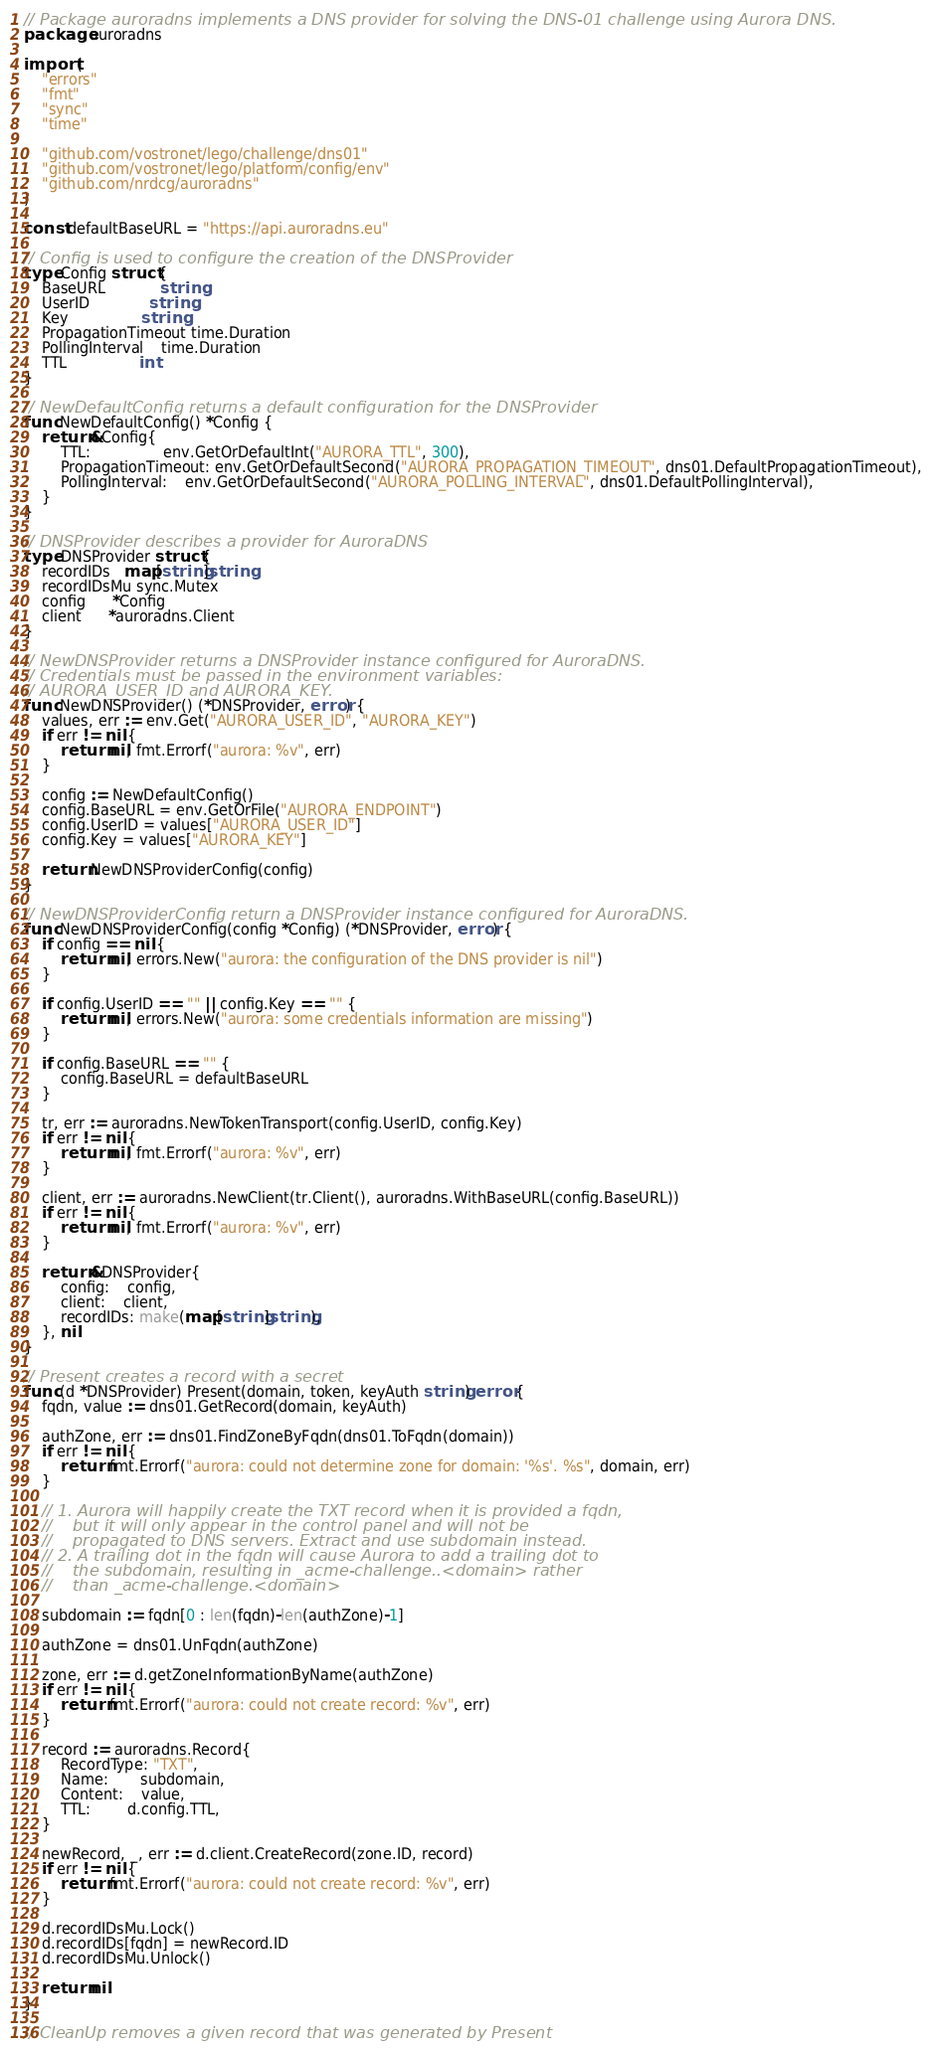<code> <loc_0><loc_0><loc_500><loc_500><_Go_>// Package auroradns implements a DNS provider for solving the DNS-01 challenge using Aurora DNS.
package auroradns

import (
	"errors"
	"fmt"
	"sync"
	"time"

	"github.com/vostronet/lego/challenge/dns01"
	"github.com/vostronet/lego/platform/config/env"
	"github.com/nrdcg/auroradns"
)

const defaultBaseURL = "https://api.auroradns.eu"

// Config is used to configure the creation of the DNSProvider
type Config struct {
	BaseURL            string
	UserID             string
	Key                string
	PropagationTimeout time.Duration
	PollingInterval    time.Duration
	TTL                int
}

// NewDefaultConfig returns a default configuration for the DNSProvider
func NewDefaultConfig() *Config {
	return &Config{
		TTL:                env.GetOrDefaultInt("AURORA_TTL", 300),
		PropagationTimeout: env.GetOrDefaultSecond("AURORA_PROPAGATION_TIMEOUT", dns01.DefaultPropagationTimeout),
		PollingInterval:    env.GetOrDefaultSecond("AURORA_POLLING_INTERVAL", dns01.DefaultPollingInterval),
	}
}

// DNSProvider describes a provider for AuroraDNS
type DNSProvider struct {
	recordIDs   map[string]string
	recordIDsMu sync.Mutex
	config      *Config
	client      *auroradns.Client
}

// NewDNSProvider returns a DNSProvider instance configured for AuroraDNS.
// Credentials must be passed in the environment variables:
// AURORA_USER_ID and AURORA_KEY.
func NewDNSProvider() (*DNSProvider, error) {
	values, err := env.Get("AURORA_USER_ID", "AURORA_KEY")
	if err != nil {
		return nil, fmt.Errorf("aurora: %v", err)
	}

	config := NewDefaultConfig()
	config.BaseURL = env.GetOrFile("AURORA_ENDPOINT")
	config.UserID = values["AURORA_USER_ID"]
	config.Key = values["AURORA_KEY"]

	return NewDNSProviderConfig(config)
}

// NewDNSProviderConfig return a DNSProvider instance configured for AuroraDNS.
func NewDNSProviderConfig(config *Config) (*DNSProvider, error) {
	if config == nil {
		return nil, errors.New("aurora: the configuration of the DNS provider is nil")
	}

	if config.UserID == "" || config.Key == "" {
		return nil, errors.New("aurora: some credentials information are missing")
	}

	if config.BaseURL == "" {
		config.BaseURL = defaultBaseURL
	}

	tr, err := auroradns.NewTokenTransport(config.UserID, config.Key)
	if err != nil {
		return nil, fmt.Errorf("aurora: %v", err)
	}

	client, err := auroradns.NewClient(tr.Client(), auroradns.WithBaseURL(config.BaseURL))
	if err != nil {
		return nil, fmt.Errorf("aurora: %v", err)
	}

	return &DNSProvider{
		config:    config,
		client:    client,
		recordIDs: make(map[string]string),
	}, nil
}

// Present creates a record with a secret
func (d *DNSProvider) Present(domain, token, keyAuth string) error {
	fqdn, value := dns01.GetRecord(domain, keyAuth)

	authZone, err := dns01.FindZoneByFqdn(dns01.ToFqdn(domain))
	if err != nil {
		return fmt.Errorf("aurora: could not determine zone for domain: '%s'. %s", domain, err)
	}

	// 1. Aurora will happily create the TXT record when it is provided a fqdn,
	//    but it will only appear in the control panel and will not be
	//    propagated to DNS servers. Extract and use subdomain instead.
	// 2. A trailing dot in the fqdn will cause Aurora to add a trailing dot to
	//    the subdomain, resulting in _acme-challenge..<domain> rather
	//    than _acme-challenge.<domain>

	subdomain := fqdn[0 : len(fqdn)-len(authZone)-1]

	authZone = dns01.UnFqdn(authZone)

	zone, err := d.getZoneInformationByName(authZone)
	if err != nil {
		return fmt.Errorf("aurora: could not create record: %v", err)
	}

	record := auroradns.Record{
		RecordType: "TXT",
		Name:       subdomain,
		Content:    value,
		TTL:        d.config.TTL,
	}

	newRecord, _, err := d.client.CreateRecord(zone.ID, record)
	if err != nil {
		return fmt.Errorf("aurora: could not create record: %v", err)
	}

	d.recordIDsMu.Lock()
	d.recordIDs[fqdn] = newRecord.ID
	d.recordIDsMu.Unlock()

	return nil
}

// CleanUp removes a given record that was generated by Present</code> 